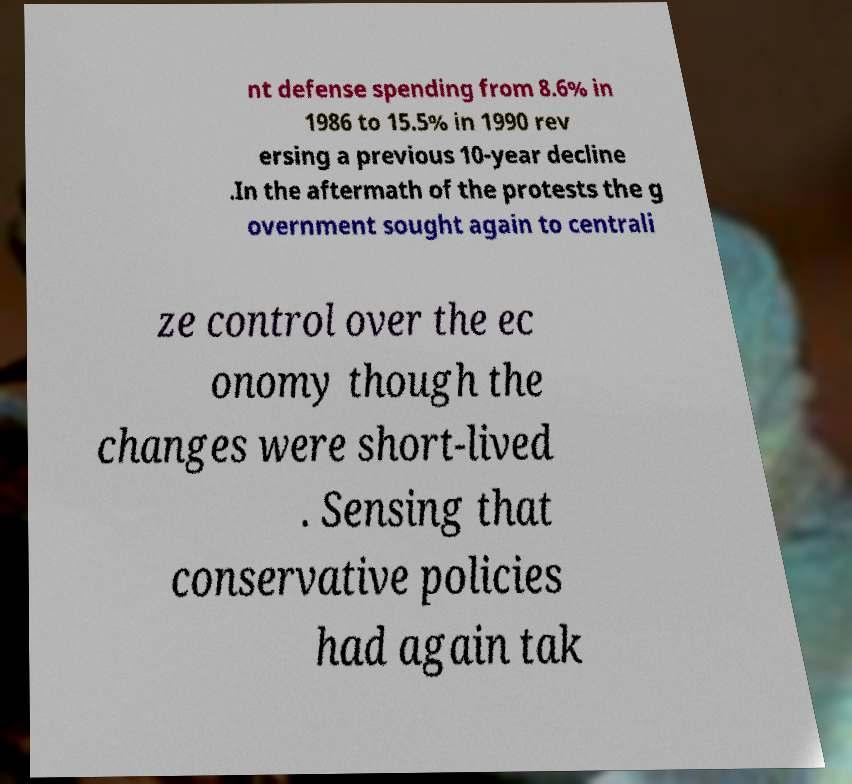Please identify and transcribe the text found in this image. nt defense spending from 8.6% in 1986 to 15.5% in 1990 rev ersing a previous 10-year decline .In the aftermath of the protests the g overnment sought again to centrali ze control over the ec onomy though the changes were short-lived . Sensing that conservative policies had again tak 